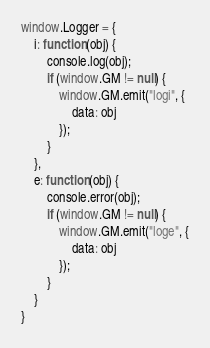<code> <loc_0><loc_0><loc_500><loc_500><_JavaScript_>window.Logger = {
    i: function (obj) {
        console.log(obj);
        if (window.GM != null) {
            window.GM.emit("logi", {
                data: obj
            });
        }
    },
    e: function (obj) {
        console.error(obj);
        if (window.GM != null) {
            window.GM.emit("loge", {
                data: obj
            });
        }
    }
}</code> 